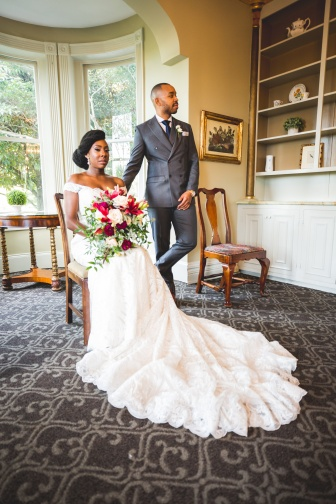What emotions does the image evoke about the couple's relationship? The image evokes a sense of deep mutual respect and admiration between the bride and groom. The groom's gaze towards the bride speaks of love and affection, while the bride's poised and tranquil demeanor suggests a graceful acceptance of those feelings. Their close proximity and the tranquil setting suggest a comfortable and intimate bond, conveying a message of unity and commitment that goes beyond the surface to the profound depths of their partnership. 